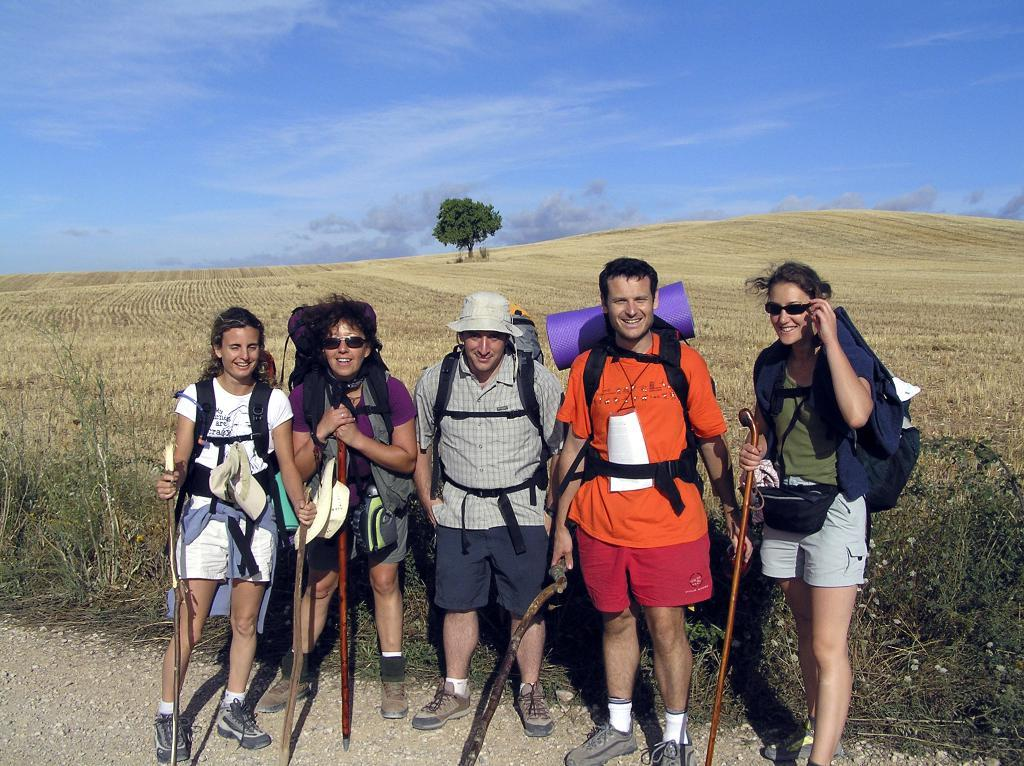How many people are in the image? There are five people in the image, three women and two men. What are the people doing in the image? The people are standing and holding sticks in their hands. What are the people wearing that are visible in the image? The people are wearing bags. What can be seen in the background of the image? There is a small plant, a tree, and the sky visible in the background. What book is the woman reading on the stage in the image? There is no book or stage present in the image. What type of skirt is the man wearing in the image? There is no skirt visible in the image, as all the people are wearing bags. 